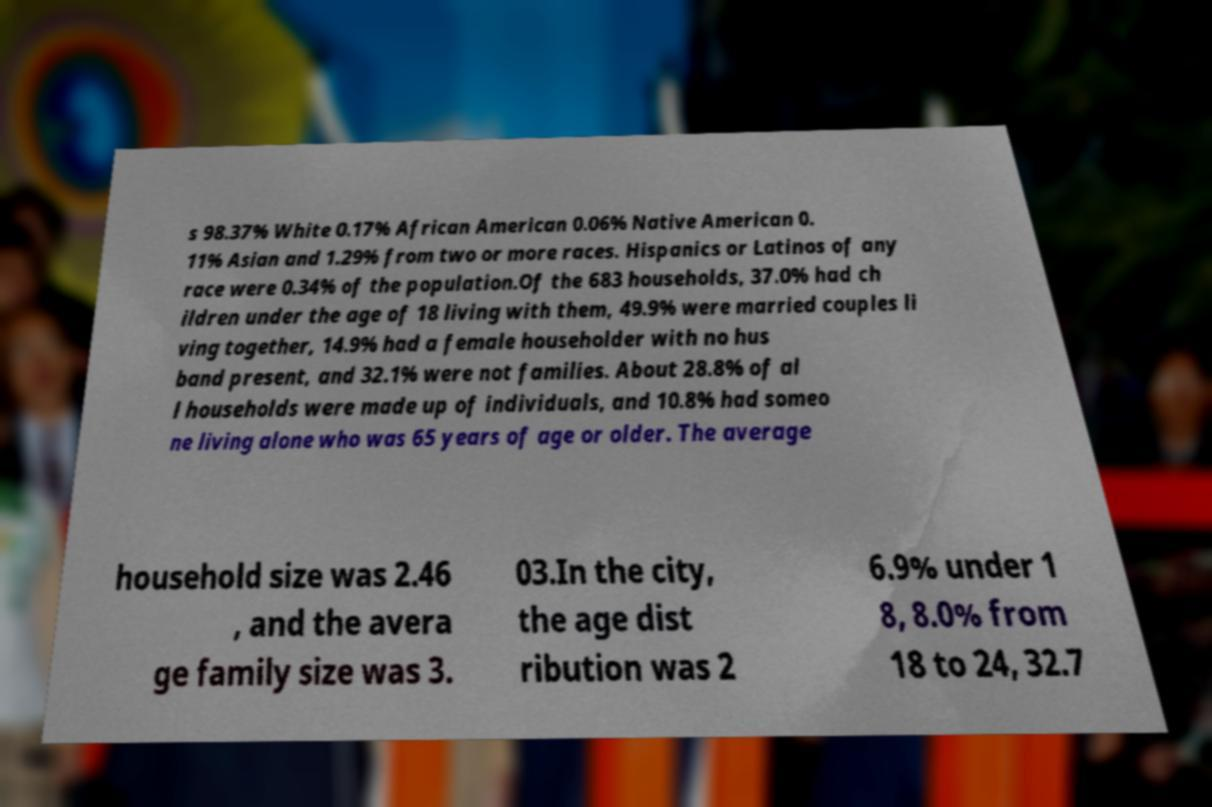I need the written content from this picture converted into text. Can you do that? s 98.37% White 0.17% African American 0.06% Native American 0. 11% Asian and 1.29% from two or more races. Hispanics or Latinos of any race were 0.34% of the population.Of the 683 households, 37.0% had ch ildren under the age of 18 living with them, 49.9% were married couples li ving together, 14.9% had a female householder with no hus band present, and 32.1% were not families. About 28.8% of al l households were made up of individuals, and 10.8% had someo ne living alone who was 65 years of age or older. The average household size was 2.46 , and the avera ge family size was 3. 03.In the city, the age dist ribution was 2 6.9% under 1 8, 8.0% from 18 to 24, 32.7 